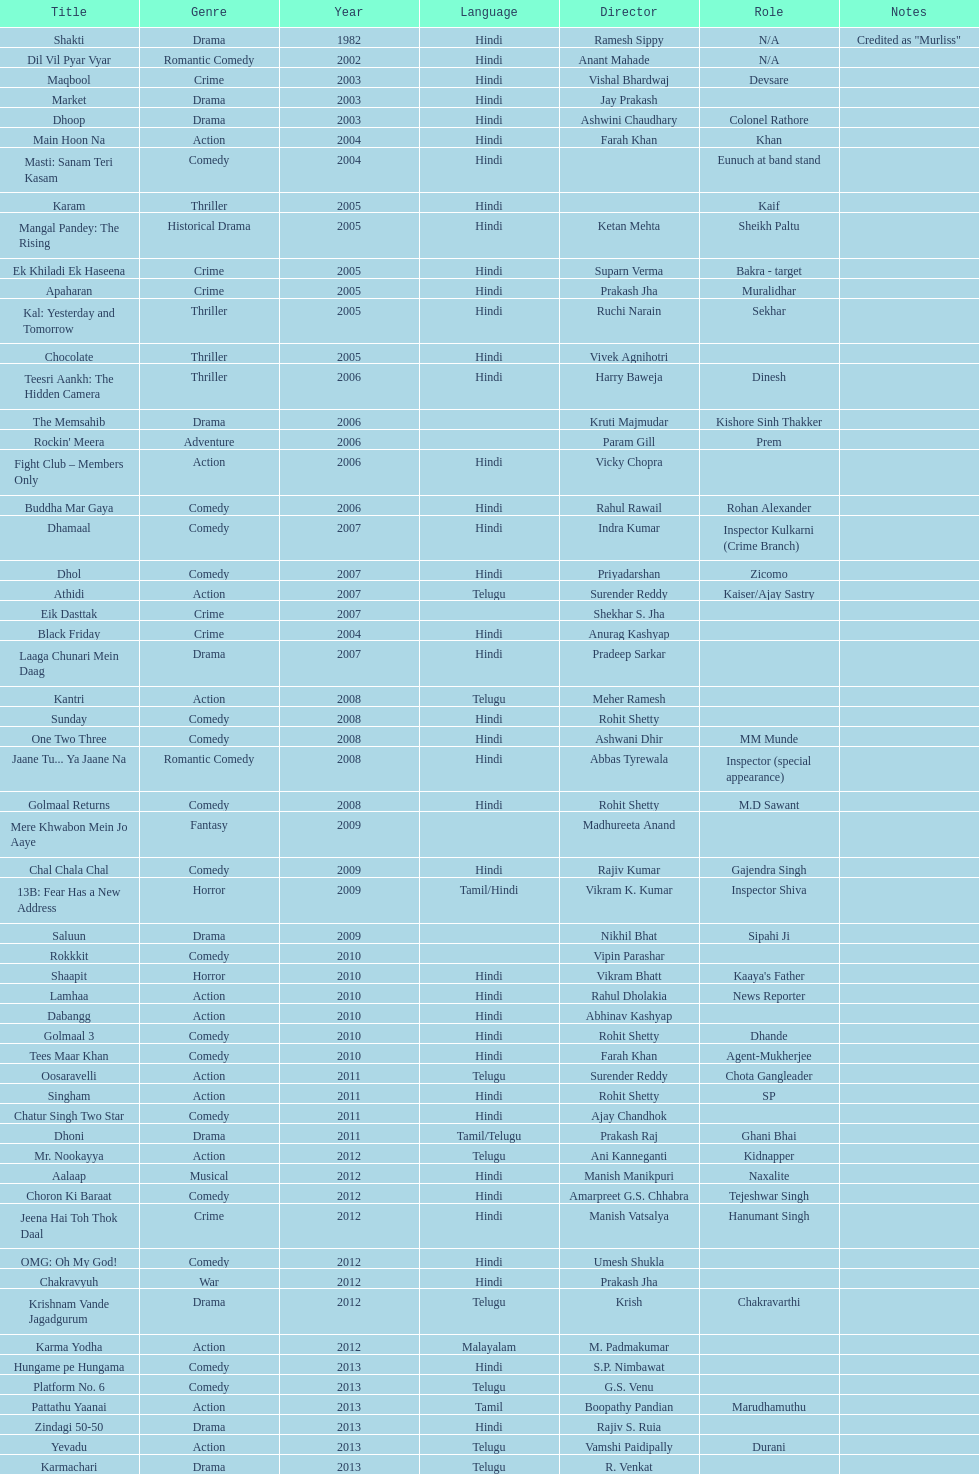What movie did this actor star in after they starred in dil vil pyar vyar in 2002? Maqbool. 